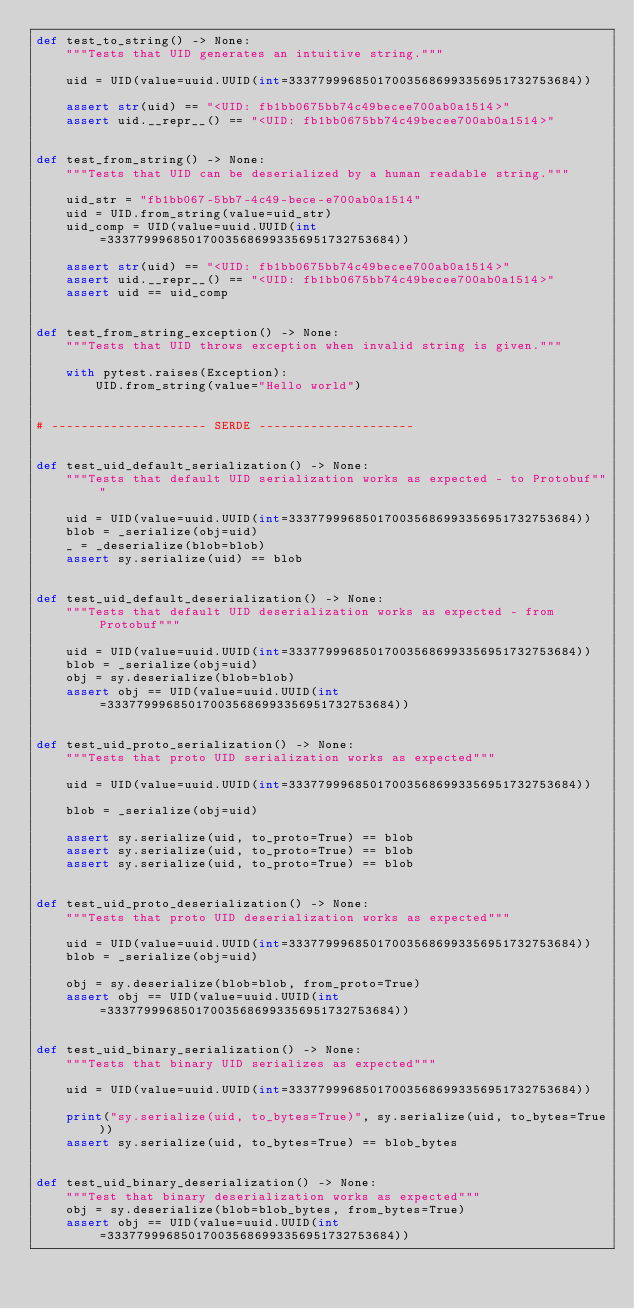<code> <loc_0><loc_0><loc_500><loc_500><_Python_>def test_to_string() -> None:
    """Tests that UID generates an intuitive string."""

    uid = UID(value=uuid.UUID(int=333779996850170035686993356951732753684))

    assert str(uid) == "<UID: fb1bb0675bb74c49becee700ab0a1514>"
    assert uid.__repr__() == "<UID: fb1bb0675bb74c49becee700ab0a1514>"


def test_from_string() -> None:
    """Tests that UID can be deserialized by a human readable string."""

    uid_str = "fb1bb067-5bb7-4c49-bece-e700ab0a1514"
    uid = UID.from_string(value=uid_str)
    uid_comp = UID(value=uuid.UUID(int=333779996850170035686993356951732753684))

    assert str(uid) == "<UID: fb1bb0675bb74c49becee700ab0a1514>"
    assert uid.__repr__() == "<UID: fb1bb0675bb74c49becee700ab0a1514>"
    assert uid == uid_comp


def test_from_string_exception() -> None:
    """Tests that UID throws exception when invalid string is given."""

    with pytest.raises(Exception):
        UID.from_string(value="Hello world")


# --------------------- SERDE ---------------------


def test_uid_default_serialization() -> None:
    """Tests that default UID serialization works as expected - to Protobuf"""

    uid = UID(value=uuid.UUID(int=333779996850170035686993356951732753684))
    blob = _serialize(obj=uid)
    _ = _deserialize(blob=blob)
    assert sy.serialize(uid) == blob


def test_uid_default_deserialization() -> None:
    """Tests that default UID deserialization works as expected - from Protobuf"""

    uid = UID(value=uuid.UUID(int=333779996850170035686993356951732753684))
    blob = _serialize(obj=uid)
    obj = sy.deserialize(blob=blob)
    assert obj == UID(value=uuid.UUID(int=333779996850170035686993356951732753684))


def test_uid_proto_serialization() -> None:
    """Tests that proto UID serialization works as expected"""

    uid = UID(value=uuid.UUID(int=333779996850170035686993356951732753684))

    blob = _serialize(obj=uid)

    assert sy.serialize(uid, to_proto=True) == blob
    assert sy.serialize(uid, to_proto=True) == blob
    assert sy.serialize(uid, to_proto=True) == blob


def test_uid_proto_deserialization() -> None:
    """Tests that proto UID deserialization works as expected"""

    uid = UID(value=uuid.UUID(int=333779996850170035686993356951732753684))
    blob = _serialize(obj=uid)

    obj = sy.deserialize(blob=blob, from_proto=True)
    assert obj == UID(value=uuid.UUID(int=333779996850170035686993356951732753684))


def test_uid_binary_serialization() -> None:
    """Tests that binary UID serializes as expected"""

    uid = UID(value=uuid.UUID(int=333779996850170035686993356951732753684))

    print("sy.serialize(uid, to_bytes=True)", sy.serialize(uid, to_bytes=True))
    assert sy.serialize(uid, to_bytes=True) == blob_bytes


def test_uid_binary_deserialization() -> None:
    """Test that binary deserialization works as expected"""
    obj = sy.deserialize(blob=blob_bytes, from_bytes=True)
    assert obj == UID(value=uuid.UUID(int=333779996850170035686993356951732753684))
</code> 